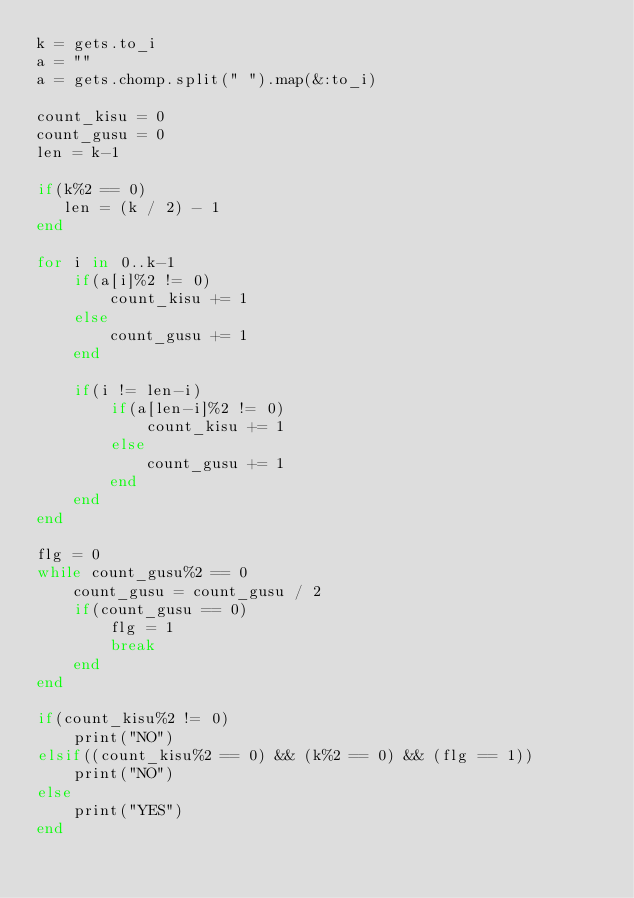Convert code to text. <code><loc_0><loc_0><loc_500><loc_500><_Ruby_>k = gets.to_i
a = ""
a = gets.chomp.split(" ").map(&:to_i)

count_kisu = 0
count_gusu = 0
len = k-1

if(k%2 == 0)
   len = (k / 2) - 1
end

for i in 0..k-1 
    if(a[i]%2 != 0)
        count_kisu += 1
    else
        count_gusu += 1
    end
        
    if(i != len-i)
        if(a[len-i]%2 != 0)
            count_kisu += 1
        else
            count_gusu += 1
        end
    end
end

flg = 0
while count_gusu%2 == 0
    count_gusu = count_gusu / 2
    if(count_gusu == 0)
        flg = 1
        break
    end
end

if(count_kisu%2 != 0)
    print("NO")
elsif((count_kisu%2 == 0) && (k%2 == 0) && (flg == 1))
    print("NO")
else
    print("YES")
end
</code> 